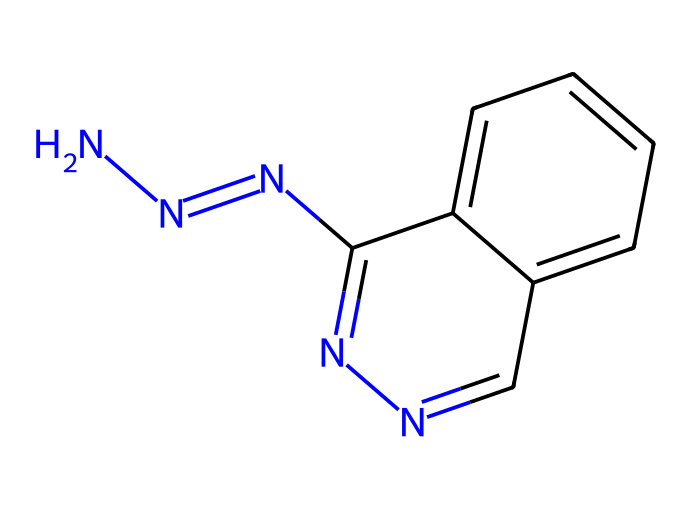What is the molecular formula of hydralazine? By analyzing the structure represented by the provided SMILES notation, we can sum the number of each type of atom present. The molecule consists of two nitrogen atoms (N), six carbon atoms (C), and seven hydrogen atoms (H). Combining these gives the molecular formula C6H8N4.
Answer: C6H8N4 How many nitrogen atoms are present in the hydralazine structure? Looking at the SMILES representation, we can see that there are four nitrogen atoms indicated by the 'N' symbols. This is a straightforward count of the nitrogen symbols in the chemical formula.
Answer: 4 What type of chemical is hydralazine classified as? Based on its structure, hydralazine contains a hydrazine functional group (N-N) along with aromatic rings, which classifies it as an antihypertensive medication. Its classification as a hydrazine derivative is also indicated by the presence of the hydrazine nitrogen configuration.
Answer: hydrazine Which functional group is characteristic of hydralazine? The structure contains a hydrazine (–N-N–) functional group, which is a defining characteristic of hydrazine derivatives. The presence of this group is critical for its activity as an antihypertensive drug.
Answer: hydrazine What is the significance of hydralazine's molecular arrangement in its function? The molecular arrangement allows for interaction with vascular smooth muscle, leading to vasodilation. The specific positioning of the nitrogen and carbon atoms influences its pharmacodynamics, making it effective in managing blood pressure, especially in pregnancy-induced hypertension.
Answer: vasodilation 